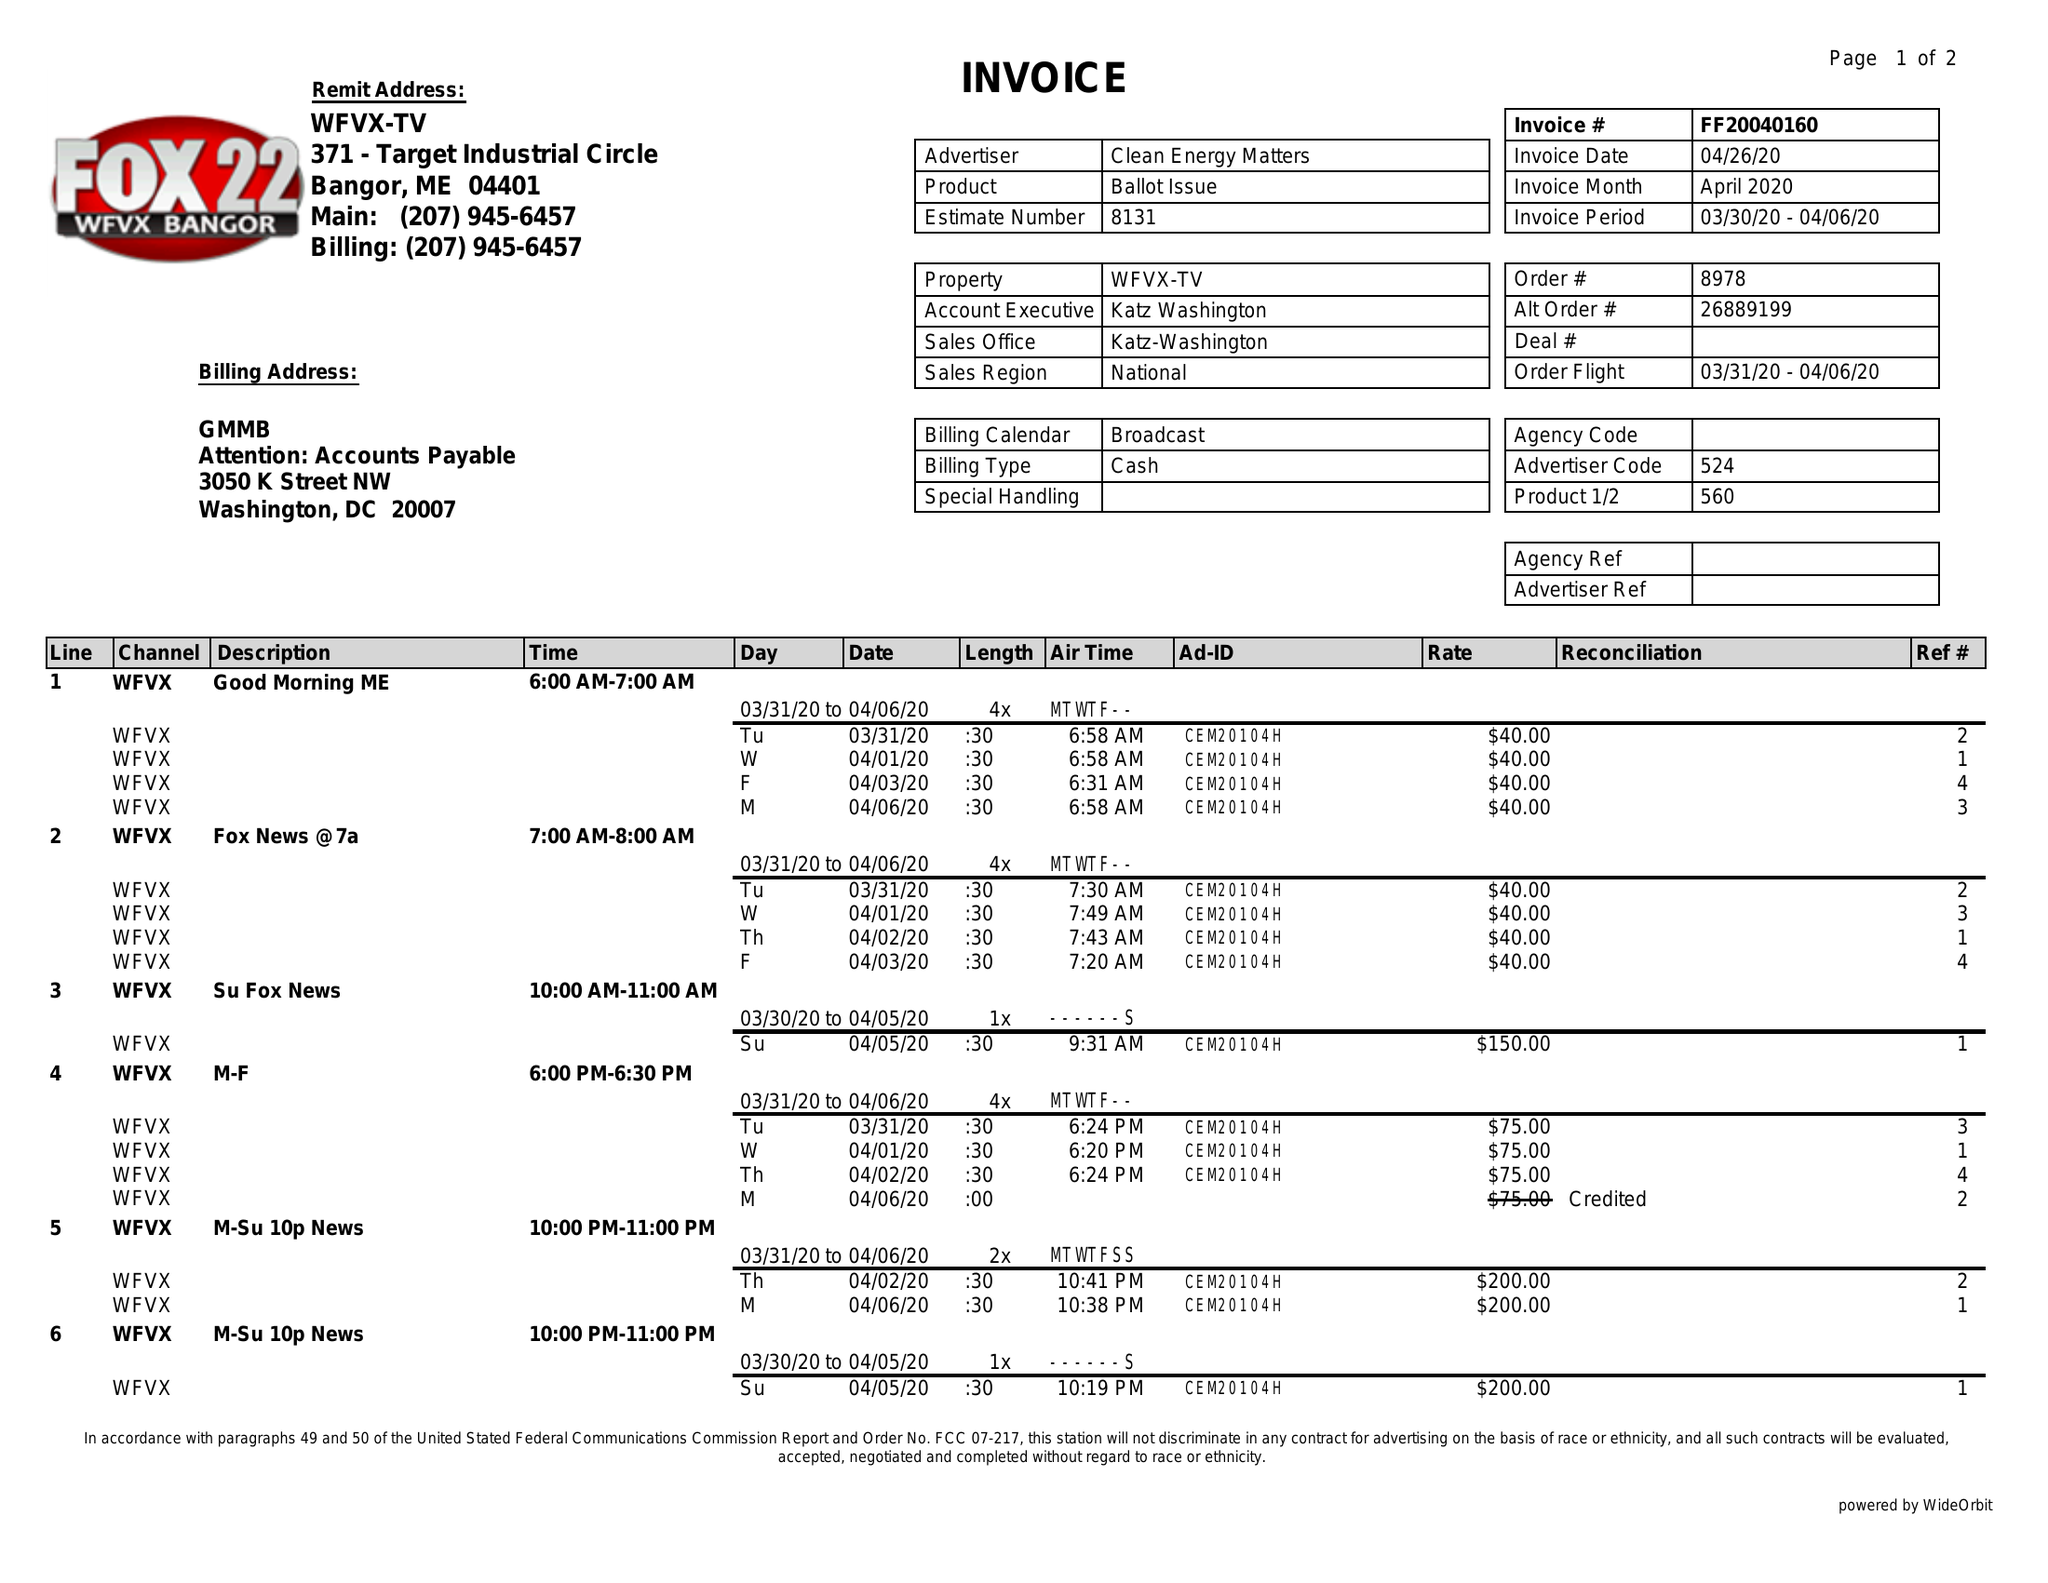What is the value for the flight_to?
Answer the question using a single word or phrase. 04/06/20 